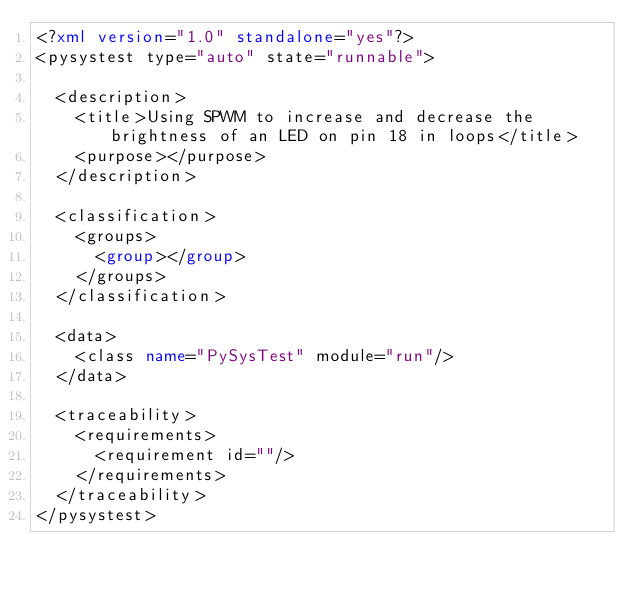Convert code to text. <code><loc_0><loc_0><loc_500><loc_500><_XML_><?xml version="1.0" standalone="yes"?>
<pysystest type="auto" state="runnable">
    
  <description> 
    <title>Using SPWM to increase and decrease the brightness of an LED on pin 18 in loops</title>    
    <purpose></purpose>
  </description>

  <classification>
    <groups>
      <group></group>
    </groups>
  </classification>

  <data>
    <class name="PySysTest" module="run"/>
  </data>
  
  <traceability>
    <requirements>
      <requirement id=""/>     
    </requirements>
  </traceability>
</pysystest>
</code> 